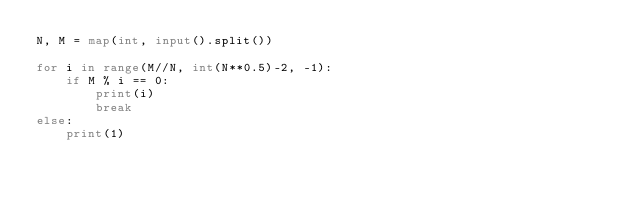Convert code to text. <code><loc_0><loc_0><loc_500><loc_500><_Python_>N, M = map(int, input().split())

for i in range(M//N, int(N**0.5)-2, -1):
    if M % i == 0:
        print(i)
        break
else:
    print(1)</code> 